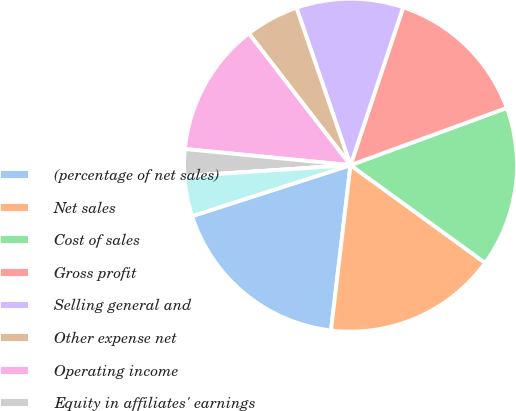Convert chart to OTSL. <chart><loc_0><loc_0><loc_500><loc_500><pie_chart><fcel>(percentage of net sales)<fcel>Net sales<fcel>Cost of sales<fcel>Gross profit<fcel>Selling general and<fcel>Other expense net<fcel>Operating income<fcel>Equity in affiliates' earnings<fcel>Interest income<fcel>Interest expense and finance<nl><fcel>18.18%<fcel>16.88%<fcel>15.58%<fcel>14.29%<fcel>10.39%<fcel>5.2%<fcel>12.99%<fcel>2.6%<fcel>0.0%<fcel>3.9%<nl></chart> 